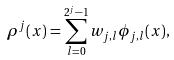<formula> <loc_0><loc_0><loc_500><loc_500>\rho ^ { j } ( x ) = \sum _ { l = 0 } ^ { 2 ^ { j } - 1 } w _ { j , l } \phi _ { j , l } ( x ) ,</formula> 